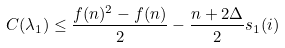Convert formula to latex. <formula><loc_0><loc_0><loc_500><loc_500>C ( \lambda _ { 1 } ) \leq \frac { f ( n ) ^ { 2 } - f ( n ) } { 2 } - \frac { n + 2 \Delta } { 2 } s _ { 1 } ( i )</formula> 